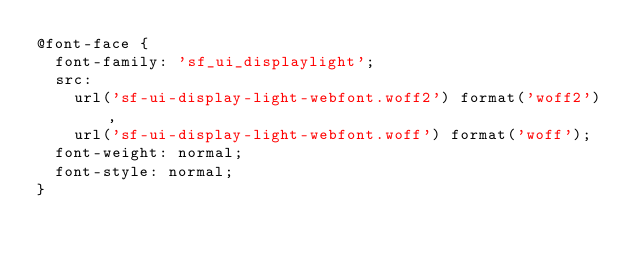<code> <loc_0><loc_0><loc_500><loc_500><_CSS_>@font-face {
  font-family: 'sf_ui_displaylight';
  src:
    url('sf-ui-display-light-webfont.woff2') format('woff2'),
    url('sf-ui-display-light-webfont.woff') format('woff');
  font-weight: normal;
  font-style: normal;
}
</code> 